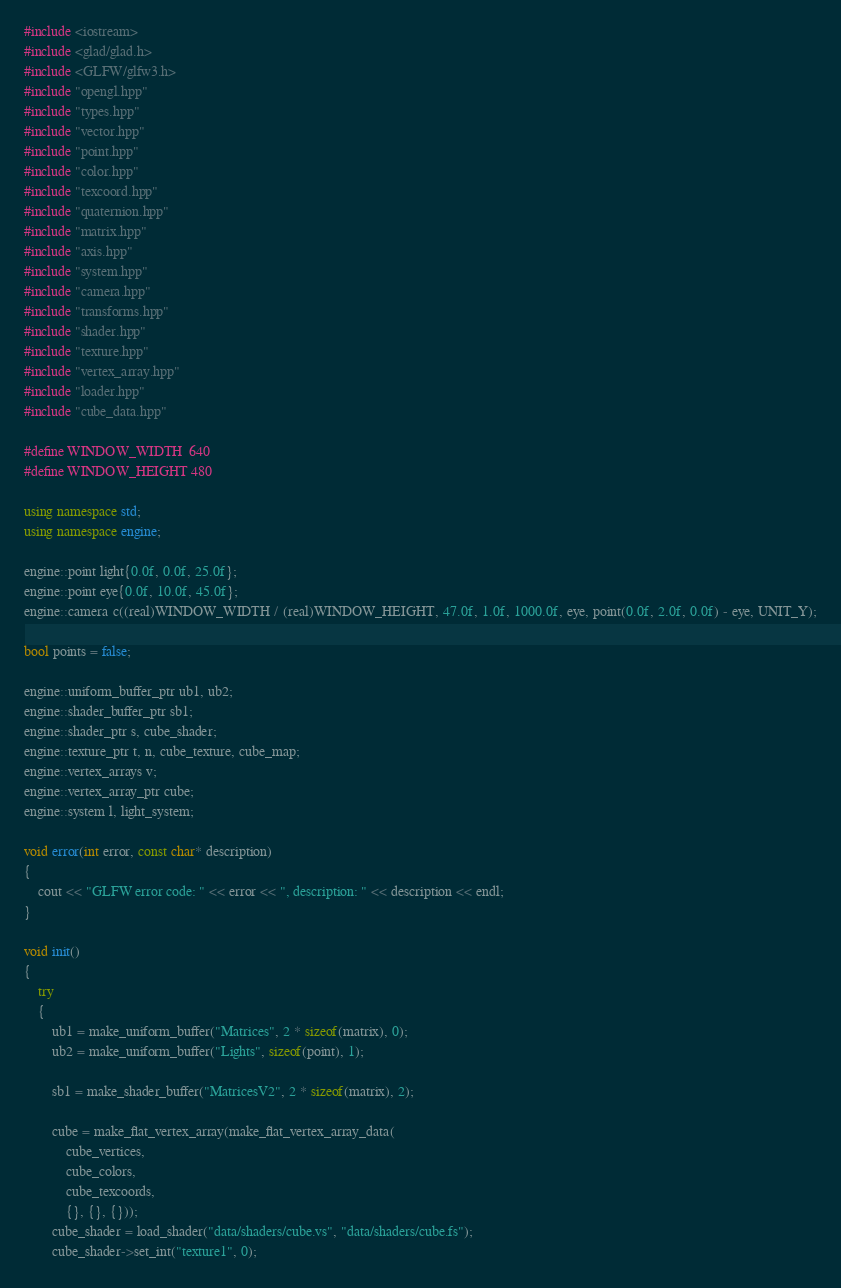<code> <loc_0><loc_0><loc_500><loc_500><_C++_>#include <iostream>
#include <glad/glad.h>
#include <GLFW/glfw3.h>
#include "opengl.hpp"
#include "types.hpp"
#include "vector.hpp"
#include "point.hpp"
#include "color.hpp"
#include "texcoord.hpp"
#include "quaternion.hpp"
#include "matrix.hpp"
#include "axis.hpp"
#include "system.hpp"
#include "camera.hpp"
#include "transforms.hpp"
#include "shader.hpp"
#include "texture.hpp"
#include "vertex_array.hpp"
#include "loader.hpp"
#include "cube_data.hpp"

#define WINDOW_WIDTH  640
#define WINDOW_HEIGHT 480

using namespace std;
using namespace engine;

engine::point light{0.0f, 0.0f, 25.0f};
engine::point eye{0.0f, 10.0f, 45.0f};
engine::camera c((real)WINDOW_WIDTH / (real)WINDOW_HEIGHT, 47.0f, 1.0f, 1000.0f, eye, point(0.0f, 2.0f, 0.0f) - eye, UNIT_Y);

bool points = false;

engine::uniform_buffer_ptr ub1, ub2;
engine::shader_buffer_ptr sb1;
engine::shader_ptr s, cube_shader;
engine::texture_ptr t, n, cube_texture, cube_map;
engine::vertex_arrays v;
engine::vertex_array_ptr cube;
engine::system l, light_system;

void error(int error, const char* description)
{
	cout << "GLFW error code: " << error << ", description: " << description << endl;
}

void init()
{
	try
	{
		ub1 = make_uniform_buffer("Matrices", 2 * sizeof(matrix), 0);
		ub2 = make_uniform_buffer("Lights", sizeof(point), 1);

		sb1 = make_shader_buffer("MatricesV2", 2 * sizeof(matrix), 2);

		cube = make_flat_vertex_array(make_flat_vertex_array_data(
			cube_vertices,
			cube_colors,
			cube_texcoords,
			{}, {}, {}));
		cube_shader = load_shader("data/shaders/cube.vs", "data/shaders/cube.fs");
		cube_shader->set_int("texture1", 0);</code> 